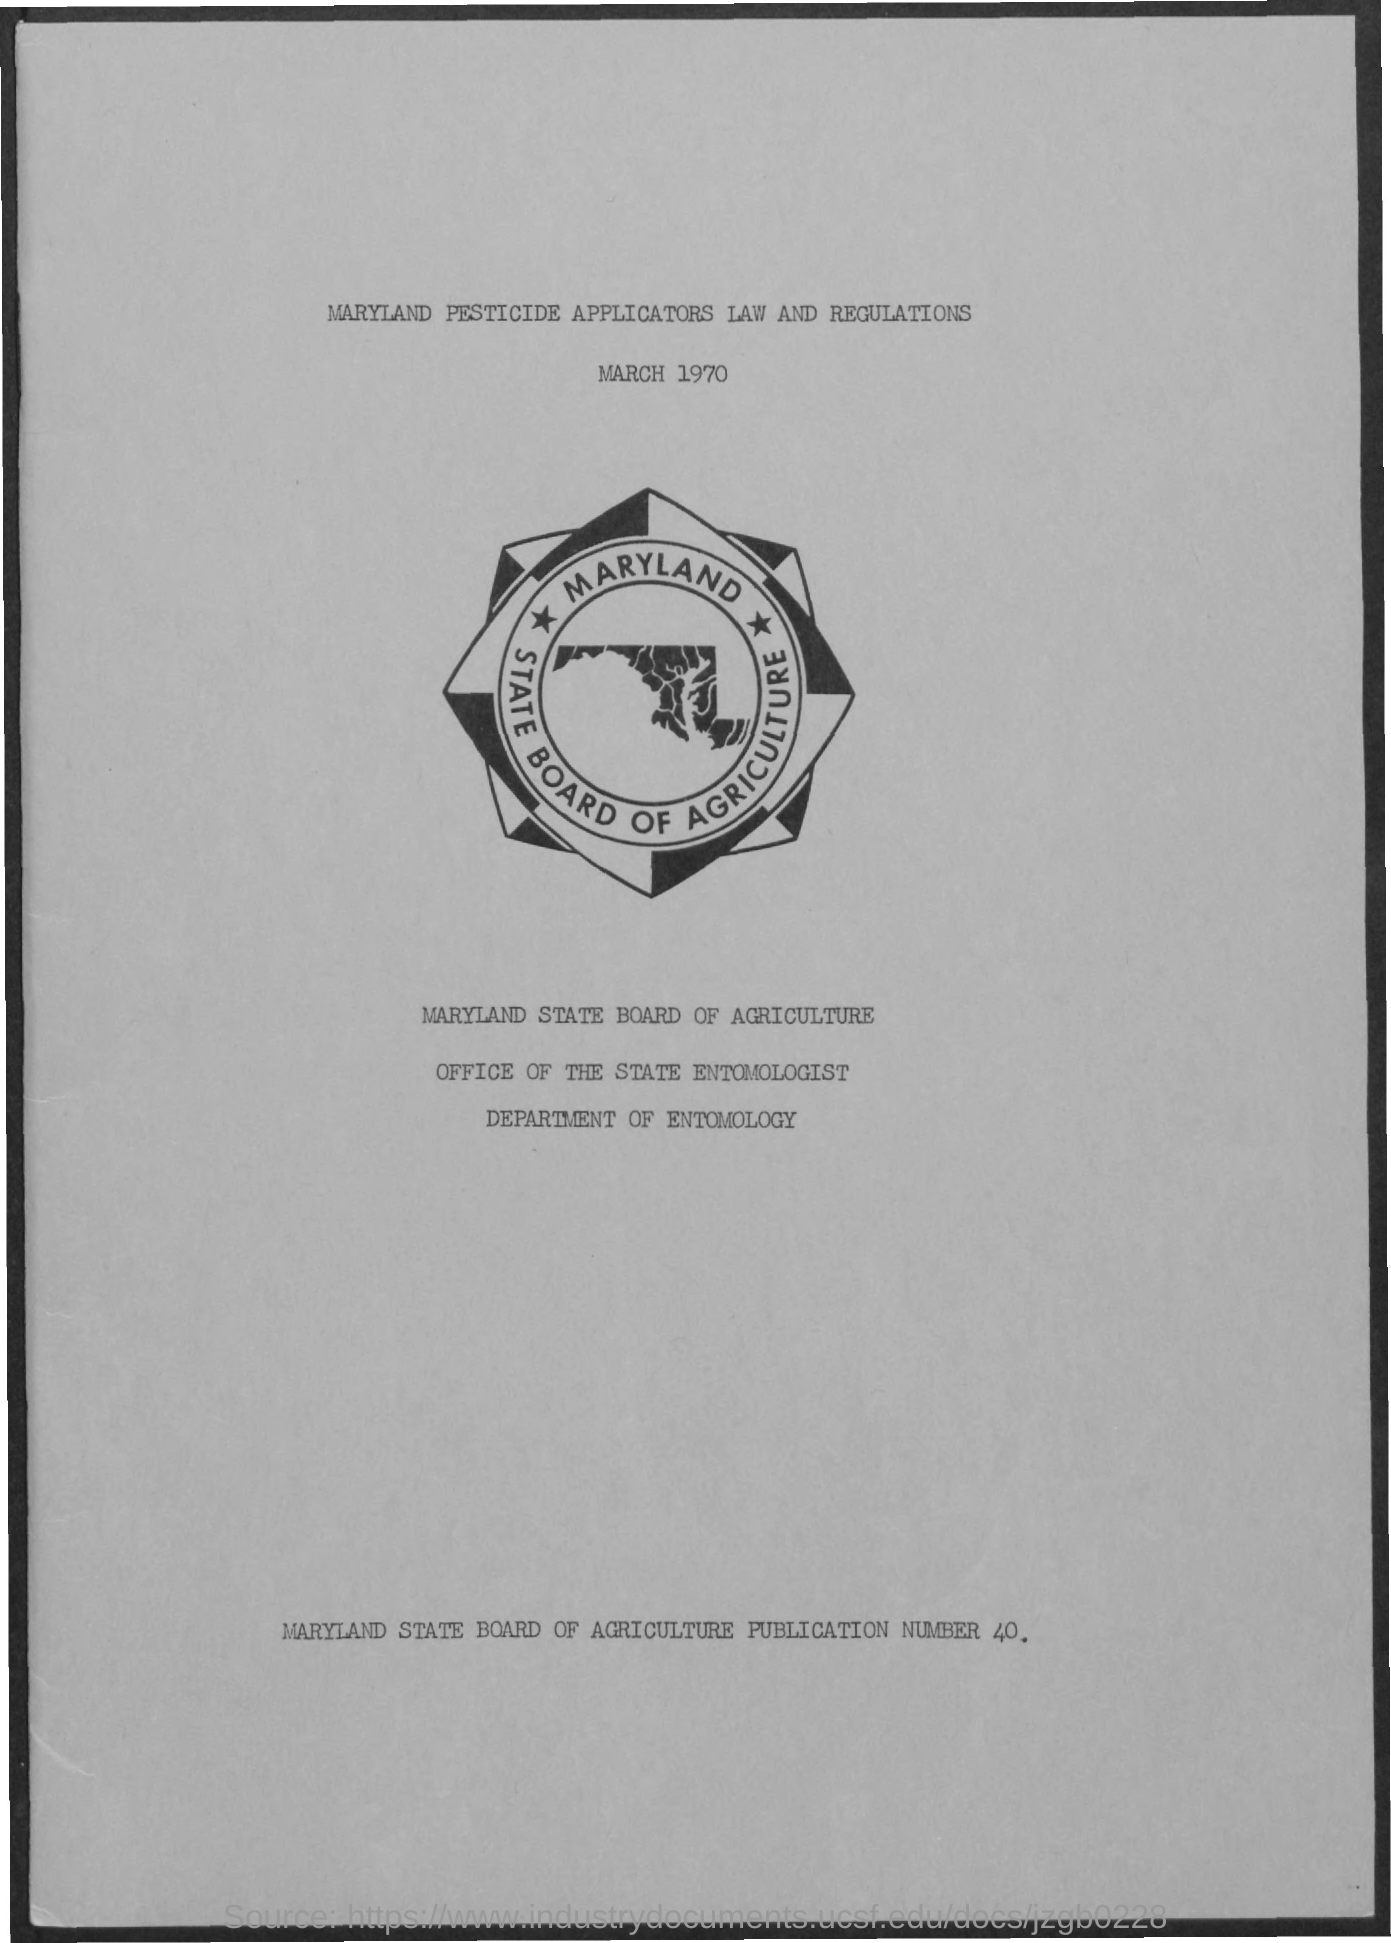What is the Date?
Provide a succinct answer. March 1970. 